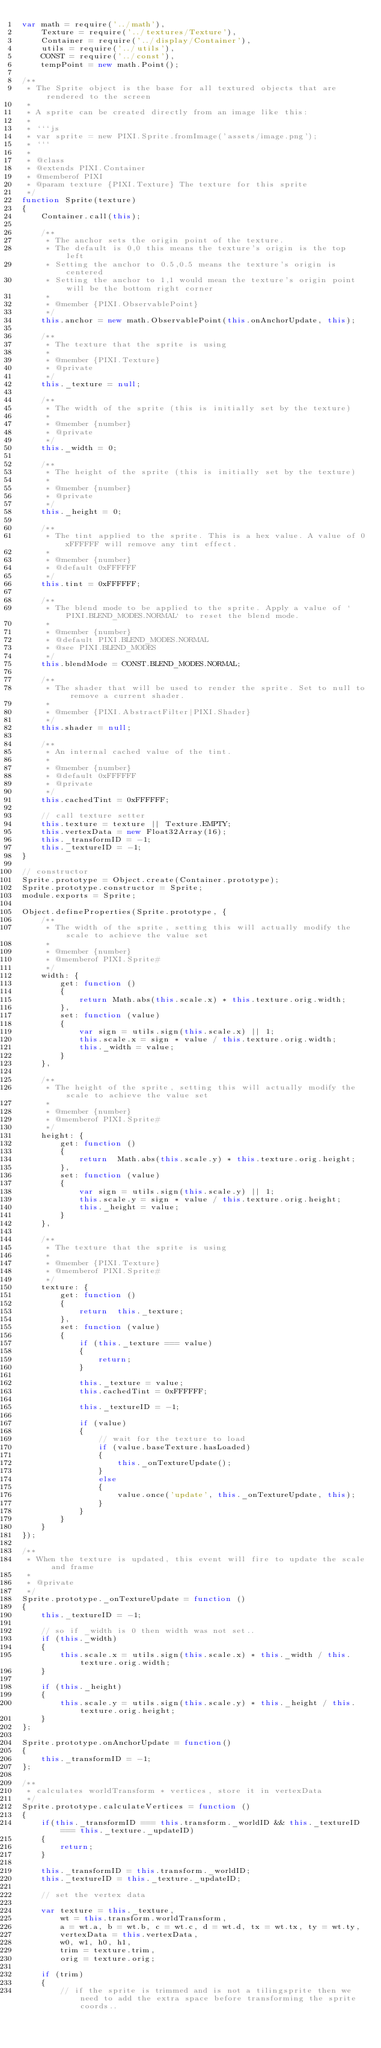Convert code to text. <code><loc_0><loc_0><loc_500><loc_500><_JavaScript_>var math = require('../math'),
    Texture = require('../textures/Texture'),
    Container = require('../display/Container'),
    utils = require('../utils'),
    CONST = require('../const'),
    tempPoint = new math.Point();

/**
 * The Sprite object is the base for all textured objects that are rendered to the screen
 *
 * A sprite can be created directly from an image like this:
 *
 * ```js
 * var sprite = new PIXI.Sprite.fromImage('assets/image.png');
 * ```
 *
 * @class
 * @extends PIXI.Container
 * @memberof PIXI
 * @param texture {PIXI.Texture} The texture for this sprite
 */
function Sprite(texture)
{
    Container.call(this);

    /**
     * The anchor sets the origin point of the texture.
     * The default is 0,0 this means the texture's origin is the top left
     * Setting the anchor to 0.5,0.5 means the texture's origin is centered
     * Setting the anchor to 1,1 would mean the texture's origin point will be the bottom right corner
     *
     * @member {PIXI.ObservablePoint}
     */
    this.anchor = new math.ObservablePoint(this.onAnchorUpdate, this);

    /**
     * The texture that the sprite is using
     *
     * @member {PIXI.Texture}
     * @private
     */
    this._texture = null;

    /**
     * The width of the sprite (this is initially set by the texture)
     *
     * @member {number}
     * @private
     */
    this._width = 0;

    /**
     * The height of the sprite (this is initially set by the texture)
     *
     * @member {number}
     * @private
     */
    this._height = 0;

    /**
     * The tint applied to the sprite. This is a hex value. A value of 0xFFFFFF will remove any tint effect.
     *
     * @member {number}
     * @default 0xFFFFFF
     */
    this.tint = 0xFFFFFF;

    /**
     * The blend mode to be applied to the sprite. Apply a value of `PIXI.BLEND_MODES.NORMAL` to reset the blend mode.
     *
     * @member {number}
     * @default PIXI.BLEND_MODES.NORMAL
     * @see PIXI.BLEND_MODES
     */
    this.blendMode = CONST.BLEND_MODES.NORMAL;

    /**
     * The shader that will be used to render the sprite. Set to null to remove a current shader.
     *
     * @member {PIXI.AbstractFilter|PIXI.Shader}
     */
    this.shader = null;

    /**
     * An internal cached value of the tint.
     *
     * @member {number}
     * @default 0xFFFFFF
     * @private
     */
    this.cachedTint = 0xFFFFFF;

    // call texture setter
    this.texture = texture || Texture.EMPTY;
    this.vertexData = new Float32Array(16);
    this._transformID = -1;
    this._textureID = -1;
}

// constructor
Sprite.prototype = Object.create(Container.prototype);
Sprite.prototype.constructor = Sprite;
module.exports = Sprite;

Object.defineProperties(Sprite.prototype, {
    /**
     * The width of the sprite, setting this will actually modify the scale to achieve the value set
     *
     * @member {number}
     * @memberof PIXI.Sprite#
     */
    width: {
        get: function ()
        {
            return Math.abs(this.scale.x) * this.texture.orig.width;
        },
        set: function (value)
        {
            var sign = utils.sign(this.scale.x) || 1;
            this.scale.x = sign * value / this.texture.orig.width;
            this._width = value;
        }
    },

    /**
     * The height of the sprite, setting this will actually modify the scale to achieve the value set
     *
     * @member {number}
     * @memberof PIXI.Sprite#
     */
    height: {
        get: function ()
        {
            return  Math.abs(this.scale.y) * this.texture.orig.height;
        },
        set: function (value)
        {
            var sign = utils.sign(this.scale.y) || 1;
            this.scale.y = sign * value / this.texture.orig.height;
            this._height = value;
        }
    },

    /**
     * The texture that the sprite is using
     *
     * @member {PIXI.Texture}
     * @memberof PIXI.Sprite#
     */
    texture: {
        get: function ()
        {
            return  this._texture;
        },
        set: function (value)
        {
            if (this._texture === value)
            {
                return;
            }

            this._texture = value;
            this.cachedTint = 0xFFFFFF;

            this._textureID = -1;

            if (value)
            {
                // wait for the texture to load
                if (value.baseTexture.hasLoaded)
                {
                    this._onTextureUpdate();
                }
                else
                {
                    value.once('update', this._onTextureUpdate, this);
                }
            }
        }
    }
});

/**
 * When the texture is updated, this event will fire to update the scale and frame
 *
 * @private
 */
Sprite.prototype._onTextureUpdate = function ()
{
    this._textureID = -1;

    // so if _width is 0 then width was not set..
    if (this._width)
    {
        this.scale.x = utils.sign(this.scale.x) * this._width / this.texture.orig.width;
    }

    if (this._height)
    {
        this.scale.y = utils.sign(this.scale.y) * this._height / this.texture.orig.height;
    }
};

Sprite.prototype.onAnchorUpdate = function()
{
    this._transformID = -1;
};

/**
 * calculates worldTransform * vertices, store it in vertexData
 */
Sprite.prototype.calculateVertices = function ()
{
    if(this._transformID === this.transform._worldID && this._textureID === this._texture._updateID)
    {
        return;
    }

    this._transformID = this.transform._worldID;
    this._textureID = this._texture._updateID;

    // set the vertex data

    var texture = this._texture,
        wt = this.transform.worldTransform,
        a = wt.a, b = wt.b, c = wt.c, d = wt.d, tx = wt.tx, ty = wt.ty,
        vertexData = this.vertexData,
        w0, w1, h0, h1,
        trim = texture.trim,
        orig = texture.orig;

    if (trim)
    {
        // if the sprite is trimmed and is not a tilingsprite then we need to add the extra space before transforming the sprite coords..</code> 